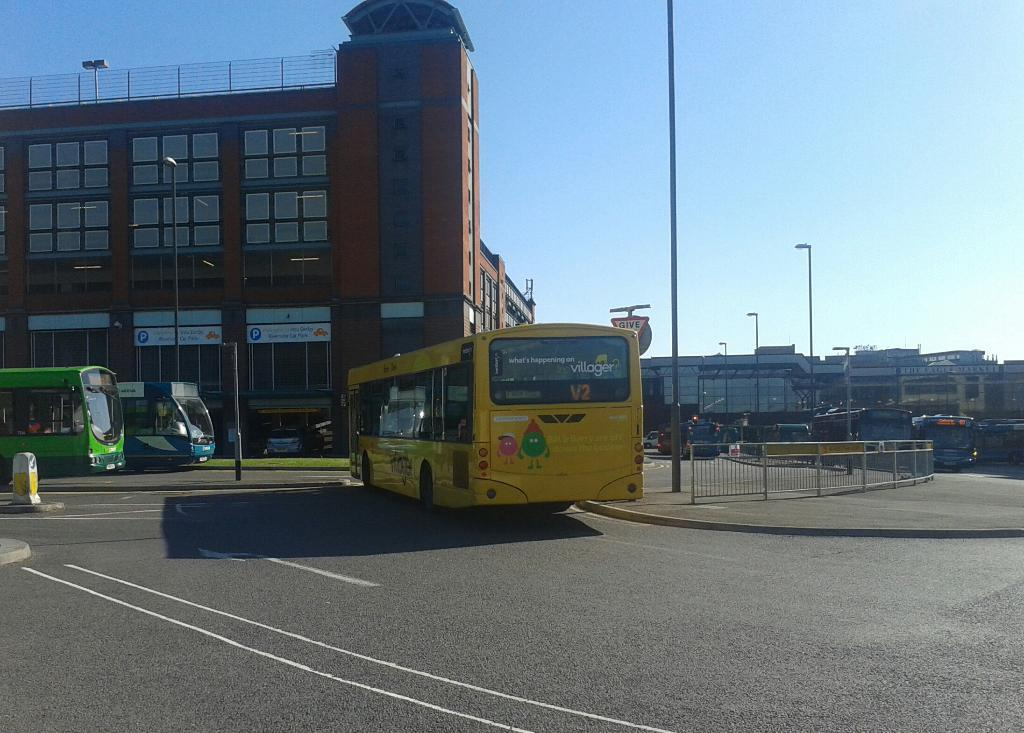What is in the foreground of the image? There is a road in the foreground of the image. What is traveling on the road? There are buses on the road. What can be seen on the pavement? There are poles and railing on the pavement. What is visible in the background of the image? There are buses, buildings, and the sky visible in the background of the image. What time of day is it in the image, and what is the baby doing in the crib? The provided facts do not mention a baby or a crib, so we cannot answer that question. The time of day cannot be determined from the image alone. 